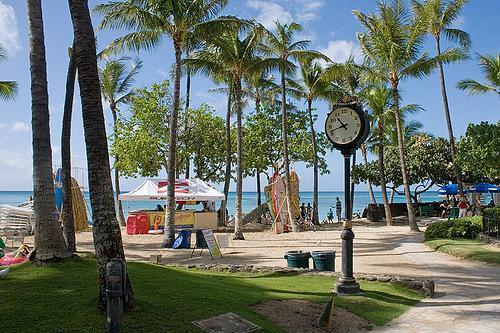How many people are in the picture?
Give a very brief answer. 5. How many buckets are in the photo?
Give a very brief answer. 2. 